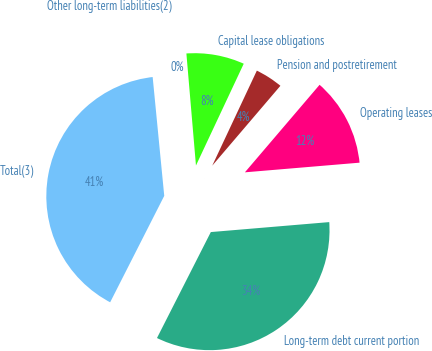<chart> <loc_0><loc_0><loc_500><loc_500><pie_chart><fcel>Long-term debt current portion<fcel>Operating leases<fcel>Pension and postretirement<fcel>Capital lease obligations<fcel>Other long-term liabilities(2)<fcel>Total(3)<nl><fcel>33.82%<fcel>12.42%<fcel>4.26%<fcel>8.34%<fcel>0.19%<fcel>40.97%<nl></chart> 